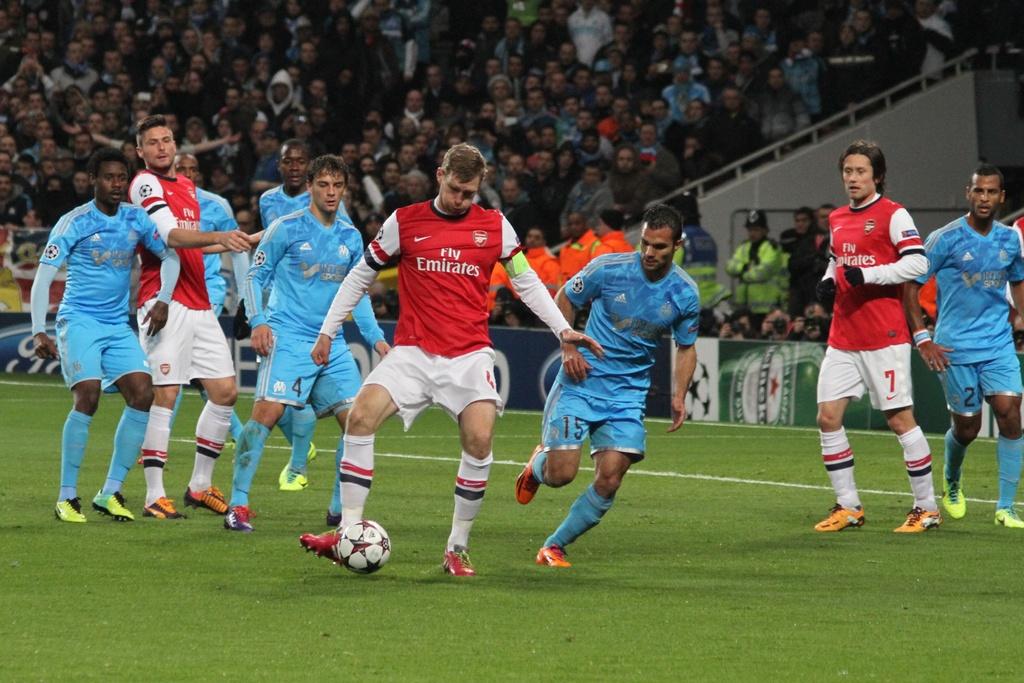What team has the ball?
Ensure brevity in your answer.  Fly emirates. What number is printed on the african american mans shorts to the very right?
Your answer should be compact. 2. 